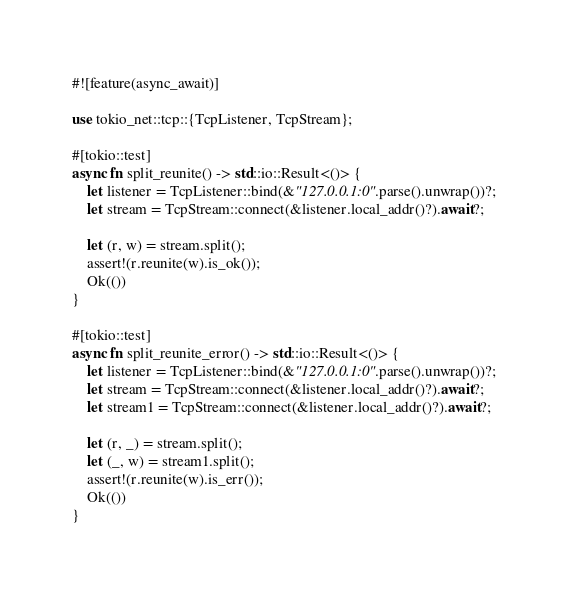Convert code to text. <code><loc_0><loc_0><loc_500><loc_500><_Rust_>#![feature(async_await)]

use tokio_net::tcp::{TcpListener, TcpStream};

#[tokio::test]
async fn split_reunite() -> std::io::Result<()> {
    let listener = TcpListener::bind(&"127.0.0.1:0".parse().unwrap())?;
    let stream = TcpStream::connect(&listener.local_addr()?).await?;

    let (r, w) = stream.split();
    assert!(r.reunite(w).is_ok());
    Ok(())
}

#[tokio::test]
async fn split_reunite_error() -> std::io::Result<()> {
    let listener = TcpListener::bind(&"127.0.0.1:0".parse().unwrap())?;
    let stream = TcpStream::connect(&listener.local_addr()?).await?;
    let stream1 = TcpStream::connect(&listener.local_addr()?).await?;

    let (r, _) = stream.split();
    let (_, w) = stream1.split();
    assert!(r.reunite(w).is_err());
    Ok(())
}
</code> 